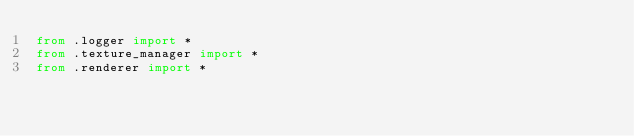<code> <loc_0><loc_0><loc_500><loc_500><_Python_>from .logger import *
from .texture_manager import *
from .renderer import *</code> 